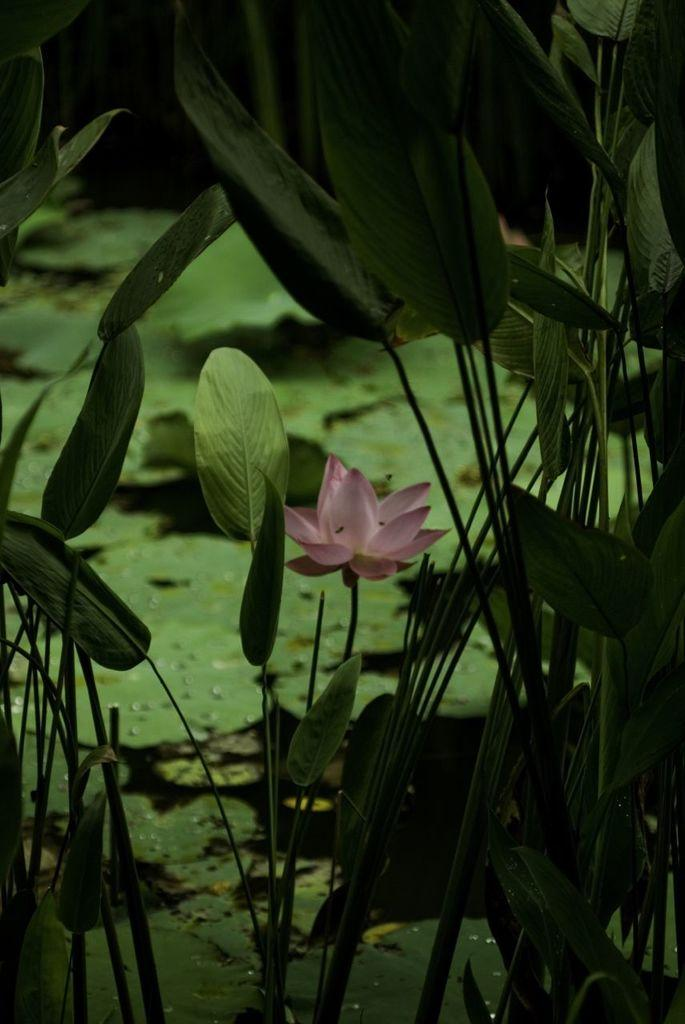What colors are the flowers in the image? There are pink flowers and green flowers in the image. What else can be seen in the background of the image? There are green leaves in the background of the image. How would you describe the overall color scheme of the image? The image has a dark background. What type of government is depicted in the image? There is no depiction of a government in the image; it features flowers and leaves. How many toes can be seen in the image? There are no toes visible in the image. 